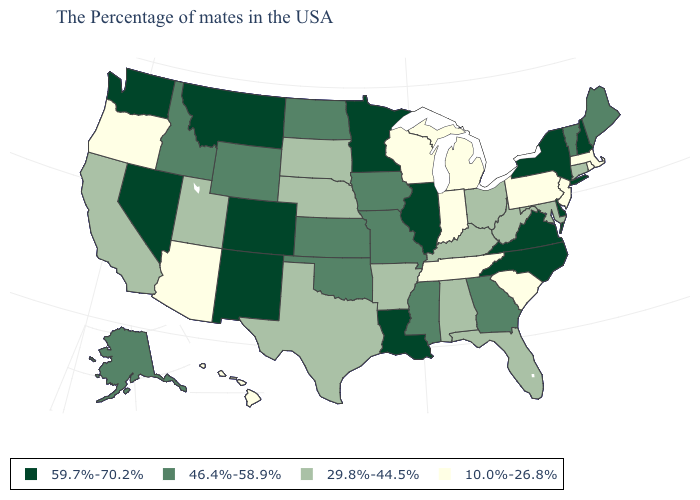Does North Carolina have the same value as New York?
Concise answer only. Yes. What is the value of Louisiana?
Keep it brief. 59.7%-70.2%. What is the value of Oklahoma?
Give a very brief answer. 46.4%-58.9%. Name the states that have a value in the range 46.4%-58.9%?
Answer briefly. Maine, Vermont, Georgia, Mississippi, Missouri, Iowa, Kansas, Oklahoma, North Dakota, Wyoming, Idaho, Alaska. What is the highest value in states that border Alabama?
Short answer required. 46.4%-58.9%. Name the states that have a value in the range 29.8%-44.5%?
Write a very short answer. Connecticut, Maryland, West Virginia, Ohio, Florida, Kentucky, Alabama, Arkansas, Nebraska, Texas, South Dakota, Utah, California. Does Indiana have the lowest value in the USA?
Concise answer only. Yes. What is the value of Wisconsin?
Concise answer only. 10.0%-26.8%. Name the states that have a value in the range 46.4%-58.9%?
Keep it brief. Maine, Vermont, Georgia, Mississippi, Missouri, Iowa, Kansas, Oklahoma, North Dakota, Wyoming, Idaho, Alaska. Among the states that border Kansas , which have the highest value?
Short answer required. Colorado. Name the states that have a value in the range 46.4%-58.9%?
Answer briefly. Maine, Vermont, Georgia, Mississippi, Missouri, Iowa, Kansas, Oklahoma, North Dakota, Wyoming, Idaho, Alaska. Is the legend a continuous bar?
Be succinct. No. Among the states that border Vermont , which have the lowest value?
Answer briefly. Massachusetts. Name the states that have a value in the range 59.7%-70.2%?
Answer briefly. New Hampshire, New York, Delaware, Virginia, North Carolina, Illinois, Louisiana, Minnesota, Colorado, New Mexico, Montana, Nevada, Washington. Does the first symbol in the legend represent the smallest category?
Answer briefly. No. 